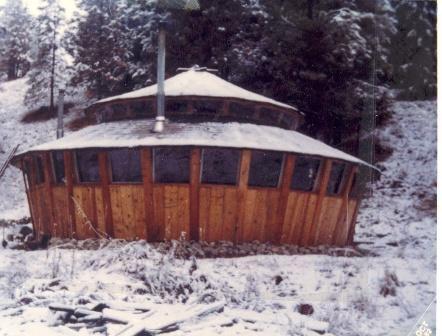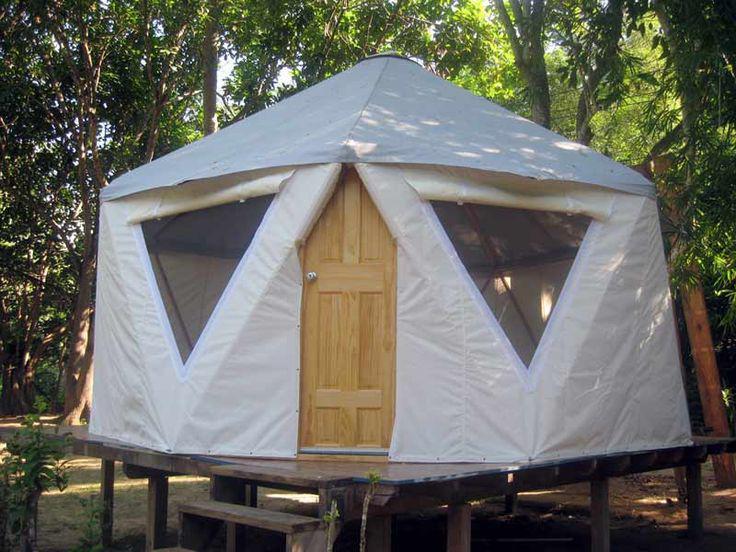The first image is the image on the left, the second image is the image on the right. Evaluate the accuracy of this statement regarding the images: "A stovepipe extends upward from the roof of the yurt in the image on the left.". Is it true? Answer yes or no. Yes. 